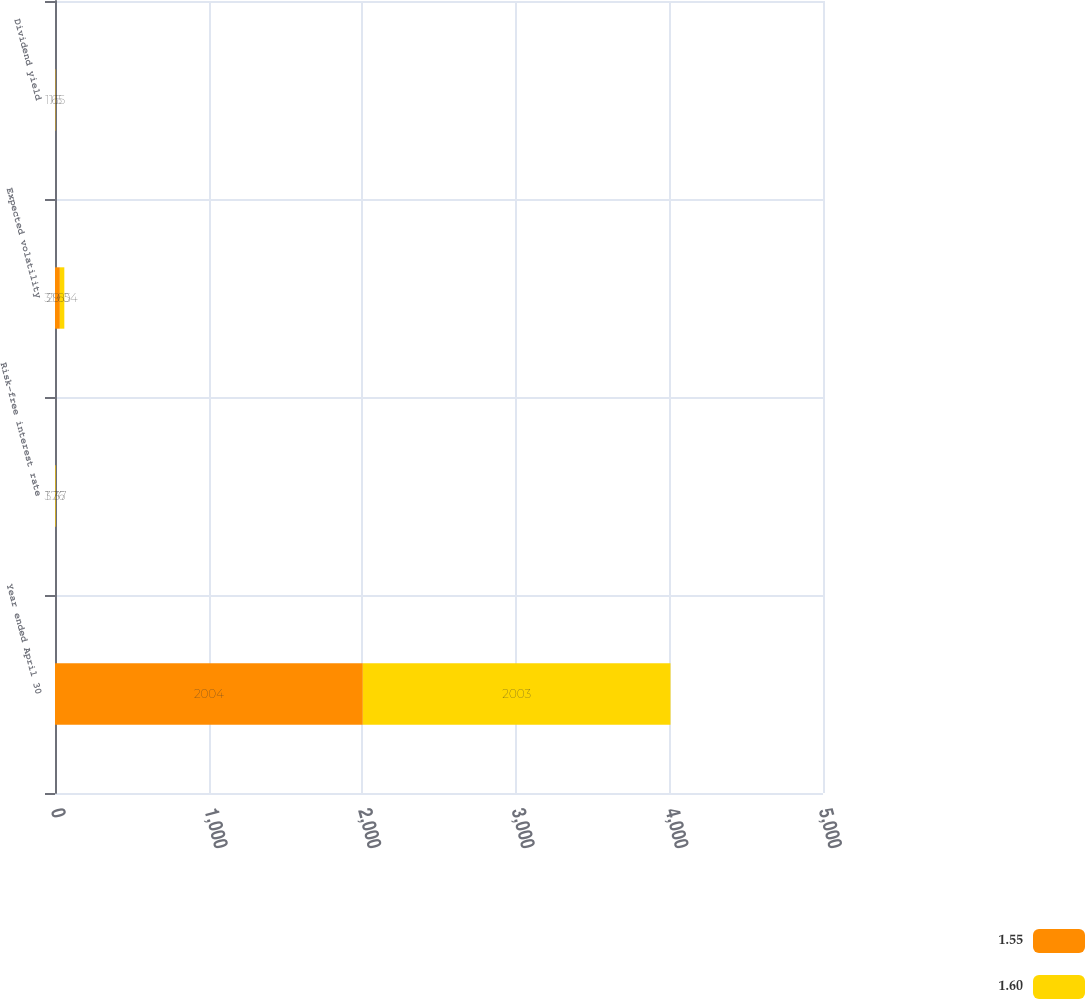Convert chart to OTSL. <chart><loc_0><loc_0><loc_500><loc_500><stacked_bar_chart><ecel><fcel>Year ended April 30<fcel>Risk-free interest rate<fcel>Expected volatility<fcel>Dividend yield<nl><fcel>1.55<fcel>2004<fcel>1.76<fcel>31.65<fcel>1.65<nl><fcel>1.6<fcel>2003<fcel>3.37<fcel>29.04<fcel>1.5<nl></chart> 